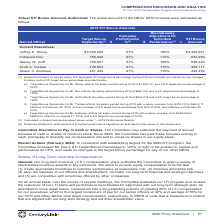According to Centurylink's financial document, How is the discretionary adjustment for individual performance determined? based on achievement of individual performance objectives. The document states: "(3) Determined based on achievement of individual performance objectives as described further above in this Subsection...." Also, What is Jeffrey K. Storey's salary earned during 2019? According to the financial document, $1,800,011. The relevant text states: ". Storey reflects his salary earned during 2019 of $1,800,011 and a STI target bonus percentage of 200%...." Also, Which current executives have a STI target bonus percentage of 120%? The document shows two values: Indraneel Dev and Stacey W. Goff. From the document: "Indraneel Dev 780,000 97% 110% 832,260 Stacey W. Goff 720,021 97% 100% 698,420..." Also, How many current executives have a STI bonus amount greater than $500,000? Counting the relevant items in the document: Jeffrey K. Storey, Indraneel Dev, Stacey W. Goff, I find 3 instances. The key data points involved are: Indraneel Dev, Jeffrey K. Storey, Stacey W. Goff. Also, can you calculate: What is Indraneel Dev's salary earned during 2019 expressed as a ratio of his/her STI bonus amount? Based on the calculation: $650,000/$832,260, the result is 78.1 (percentage). This is based on the information: "Indraneel Dev 780,000 97% 110% 832,260 r. Dev reflects his salary earned during 2019 of $650,000 and a STI target bonus percentage of 120%...." The key data points involved are: 650,000, 832,260. Also, can you calculate: What is the percentage change of Scott A. Trezise's salary increase? To answer this question, I need to perform calculations using the financial data. The calculation is: ($500,011-$475,010)/$475,010, which equals 5.26 (percentage). This is based on the information: "earned during 2019 with a salary increase, from $475,010 to $500,011, effective on February 23, 2019, and an increase of STI target bonus percentage from 80 ng 2019 with a salary increase, from $475,0..." The key data points involved are: 475,010, 500,011. 